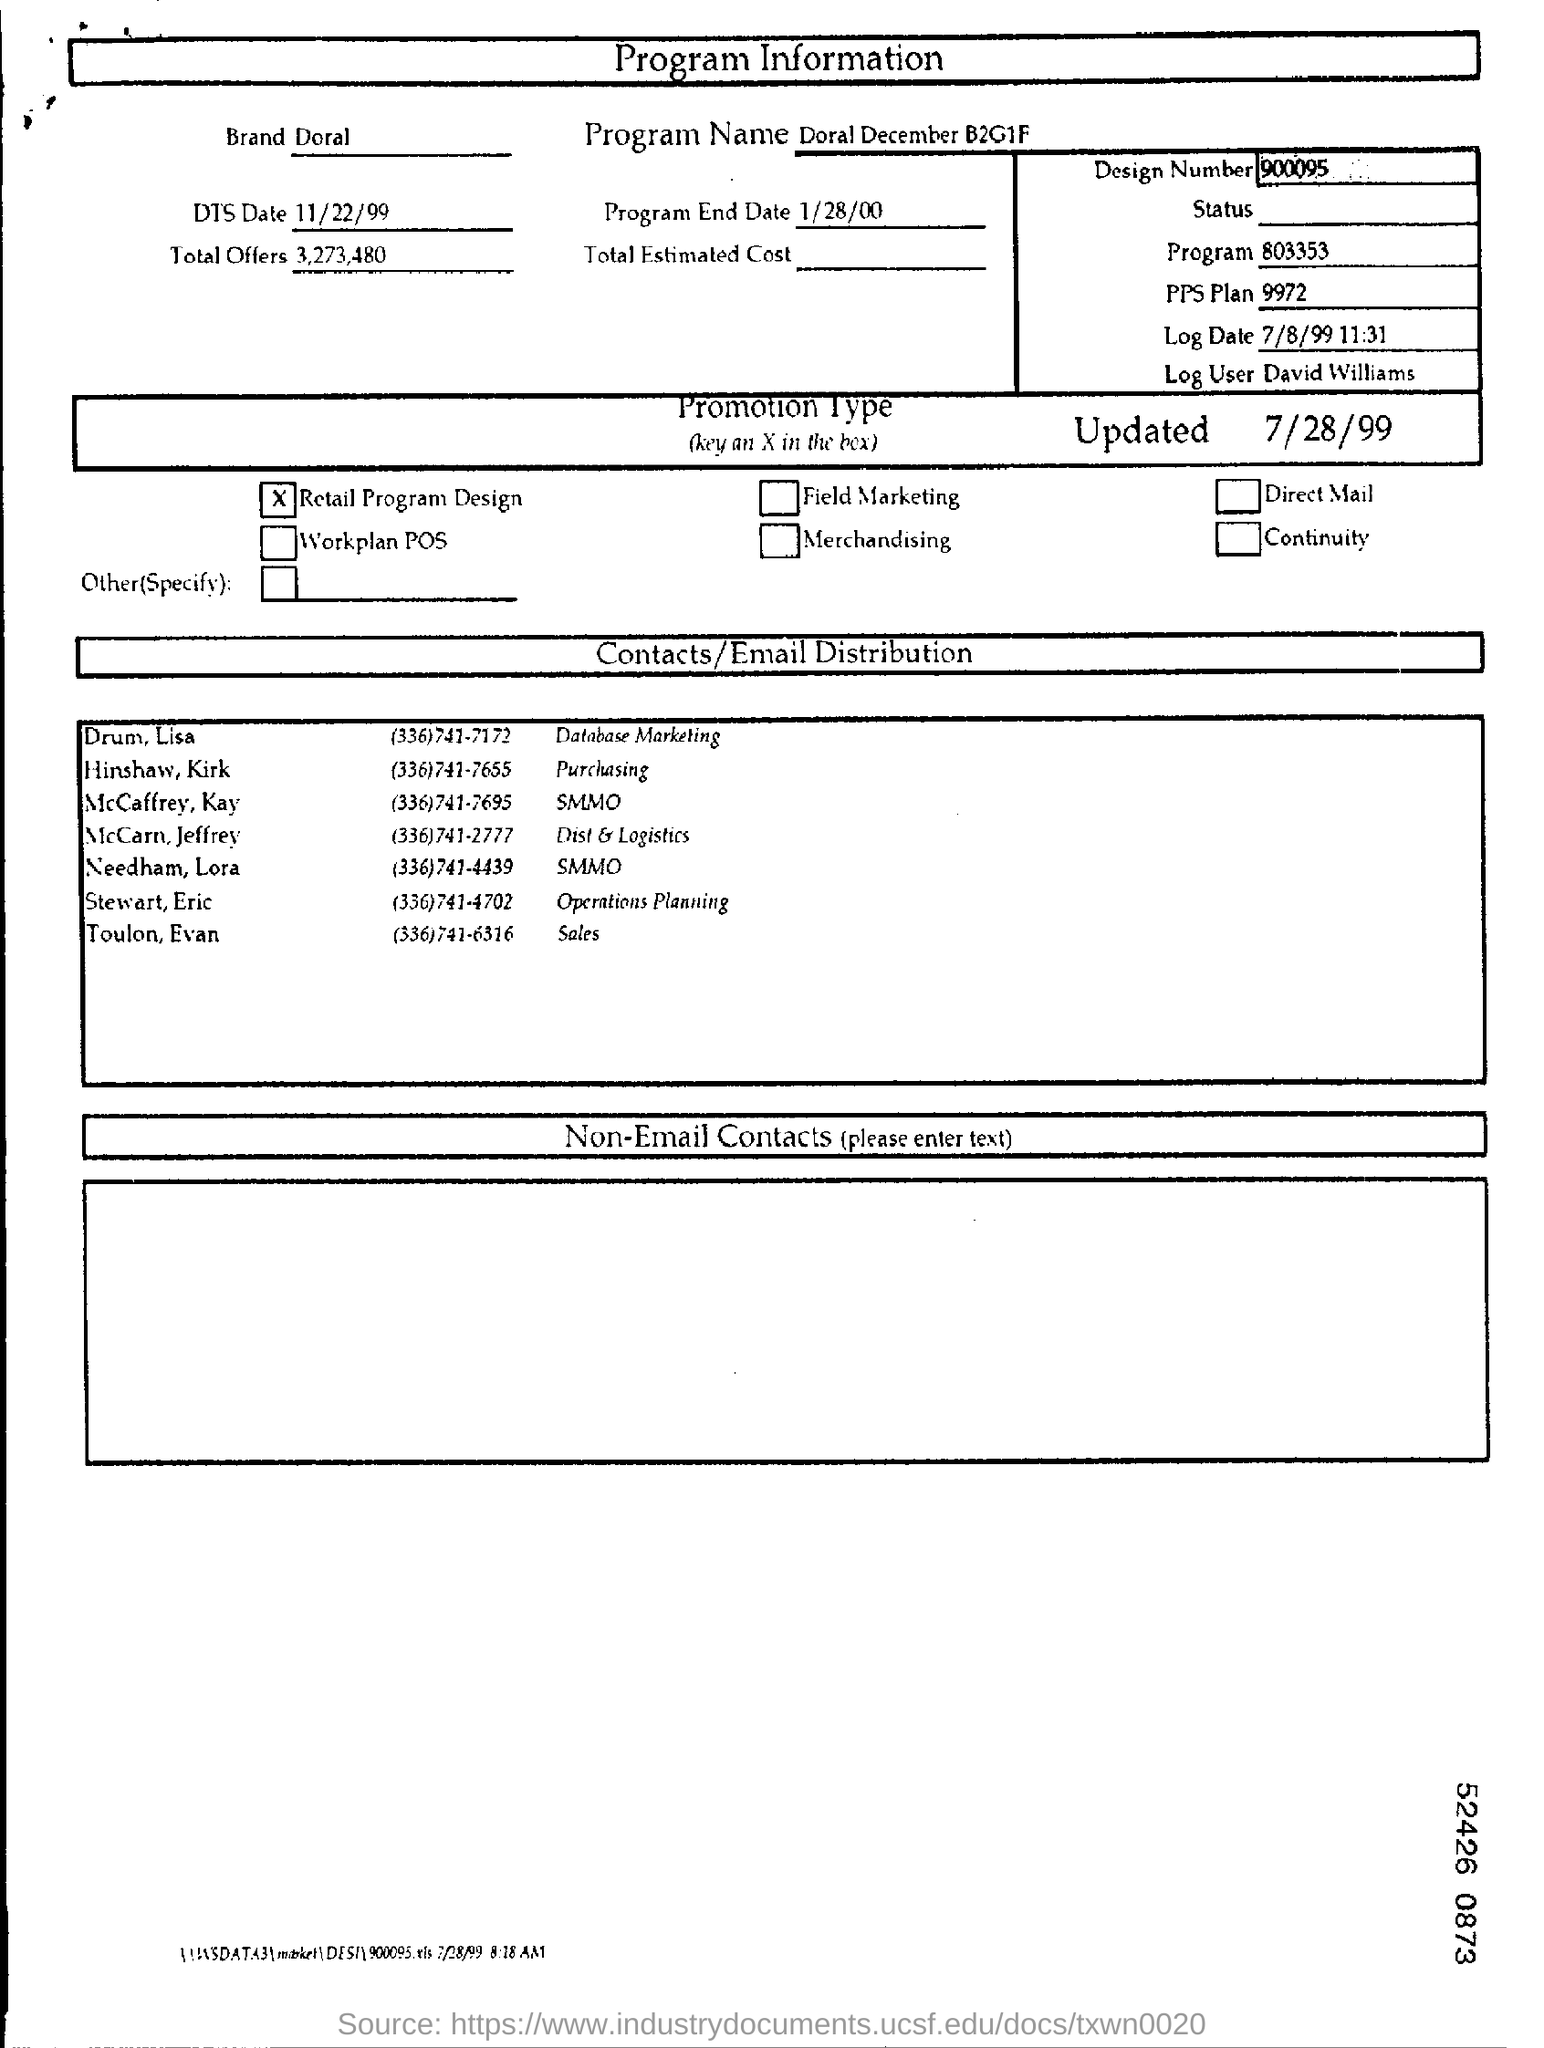What is the Design Number?
Your response must be concise. 900095. Who is the log user?
Provide a succinct answer. David Williams. What is the promotion type?
Give a very brief answer. Retail program design. What is the DTS Date?
Your answer should be compact. 11/22/99. How many total offers?
Your response must be concise. 3,273,480. 